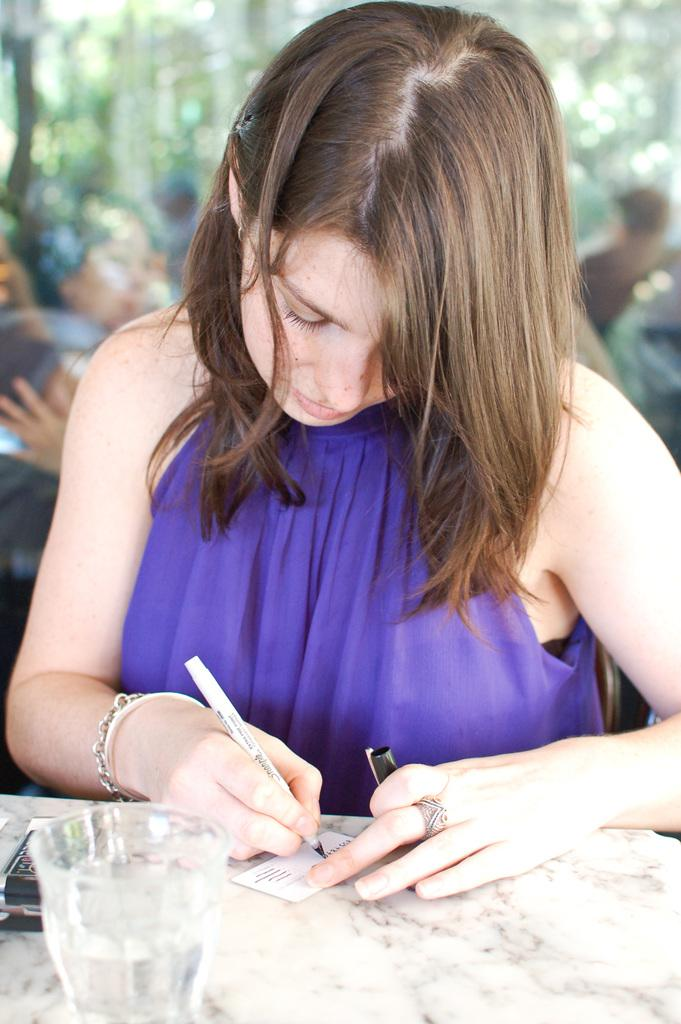Who is the main subject in the image? There is a lady in the image. What is the lady holding in her hand? The lady is holding a pen. What is the lady doing with the pen? The lady is writing on a card. What can be seen on the table in the image? There is a glass on the table. Can you describe the background of the image? The background of the image is not clear. What type of trains can be seen in the image? There are no trains present in the image. What operation is the lady performing on the card? The lady is simply writing on the card, and there is no indication of any specific operation being performed. 